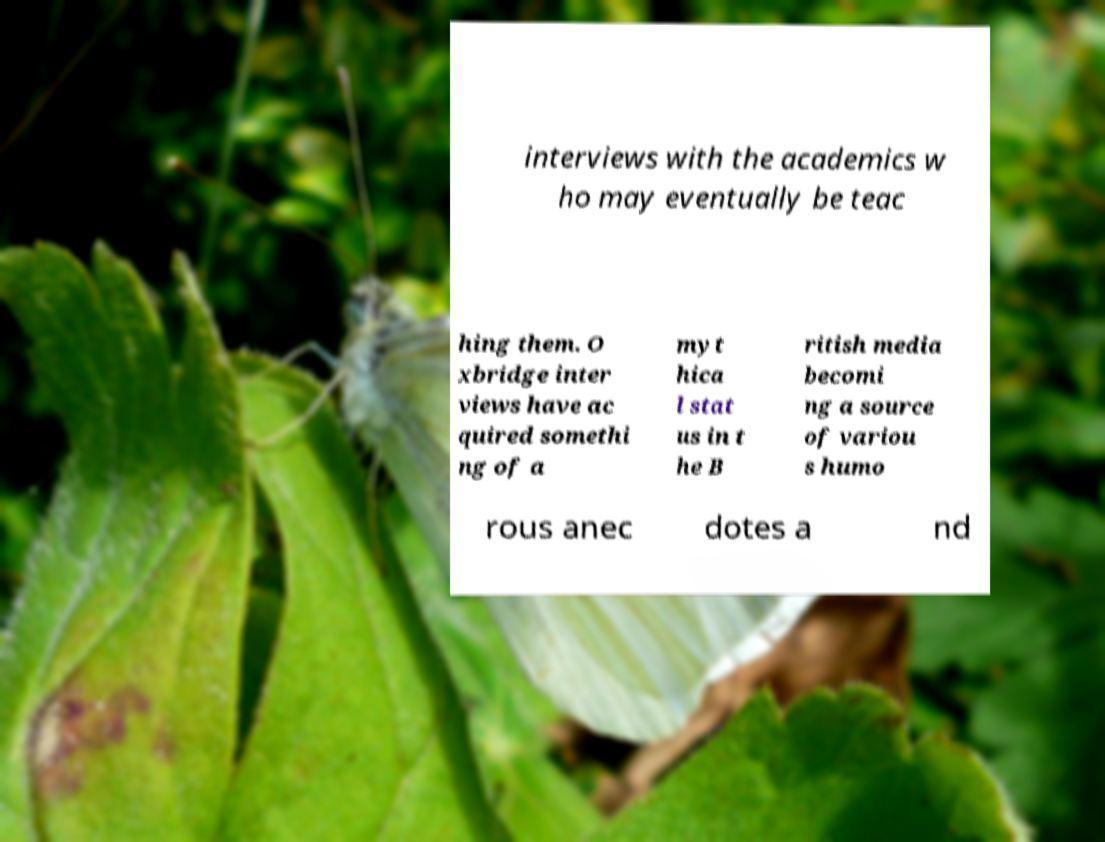Can you accurately transcribe the text from the provided image for me? interviews with the academics w ho may eventually be teac hing them. O xbridge inter views have ac quired somethi ng of a myt hica l stat us in t he B ritish media becomi ng a source of variou s humo rous anec dotes a nd 